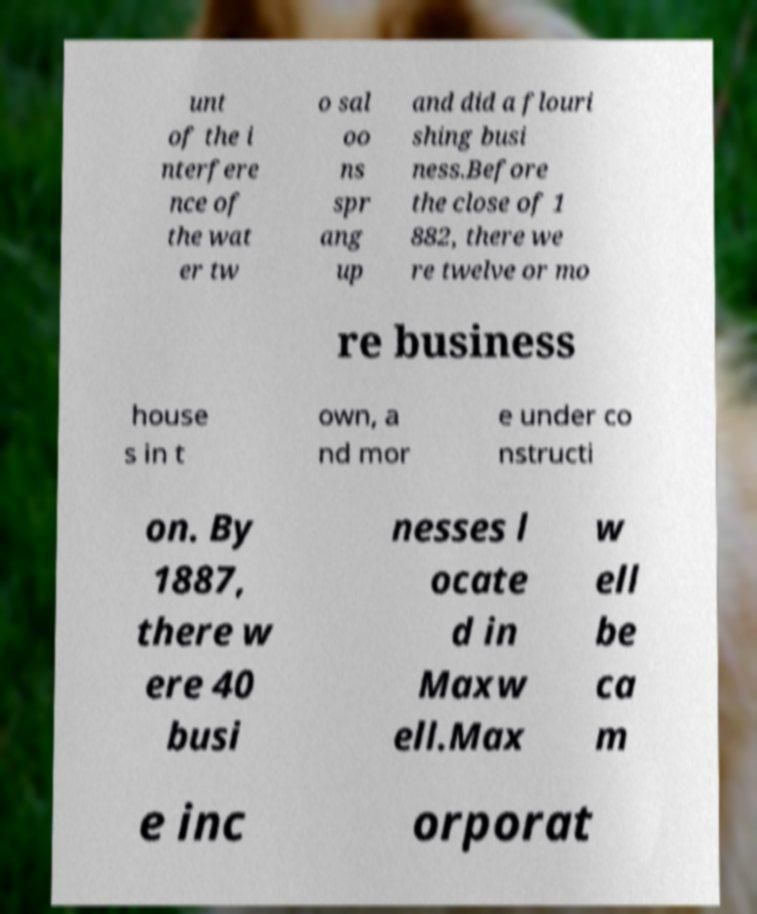Please read and relay the text visible in this image. What does it say? unt of the i nterfere nce of the wat er tw o sal oo ns spr ang up and did a flouri shing busi ness.Before the close of 1 882, there we re twelve or mo re business house s in t own, a nd mor e under co nstructi on. By 1887, there w ere 40 busi nesses l ocate d in Maxw ell.Max w ell be ca m e inc orporat 